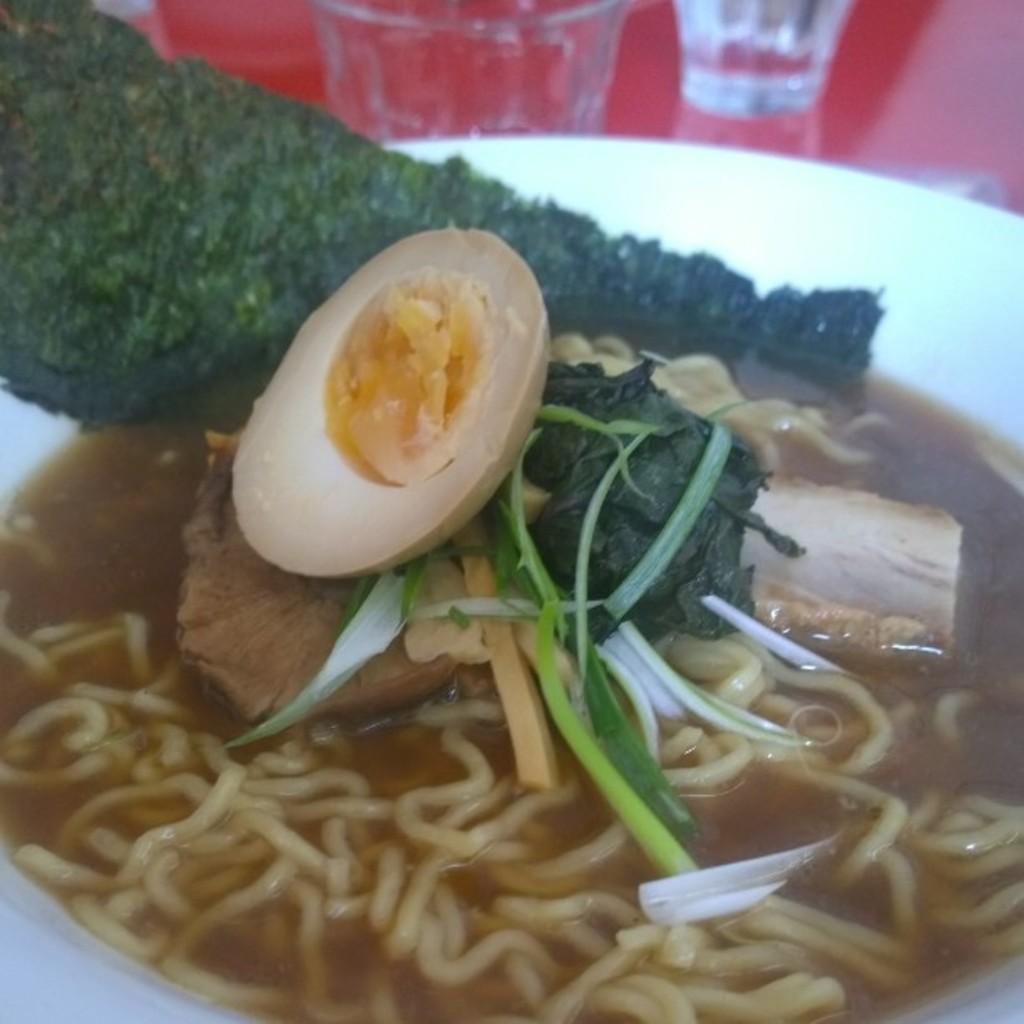How would you summarize this image in a sentence or two? In this picture we can observe some food placed in this white color bowl. There are noodles, egg and green color vegetables placed in this bowl. There are some glasses on the red color table. 